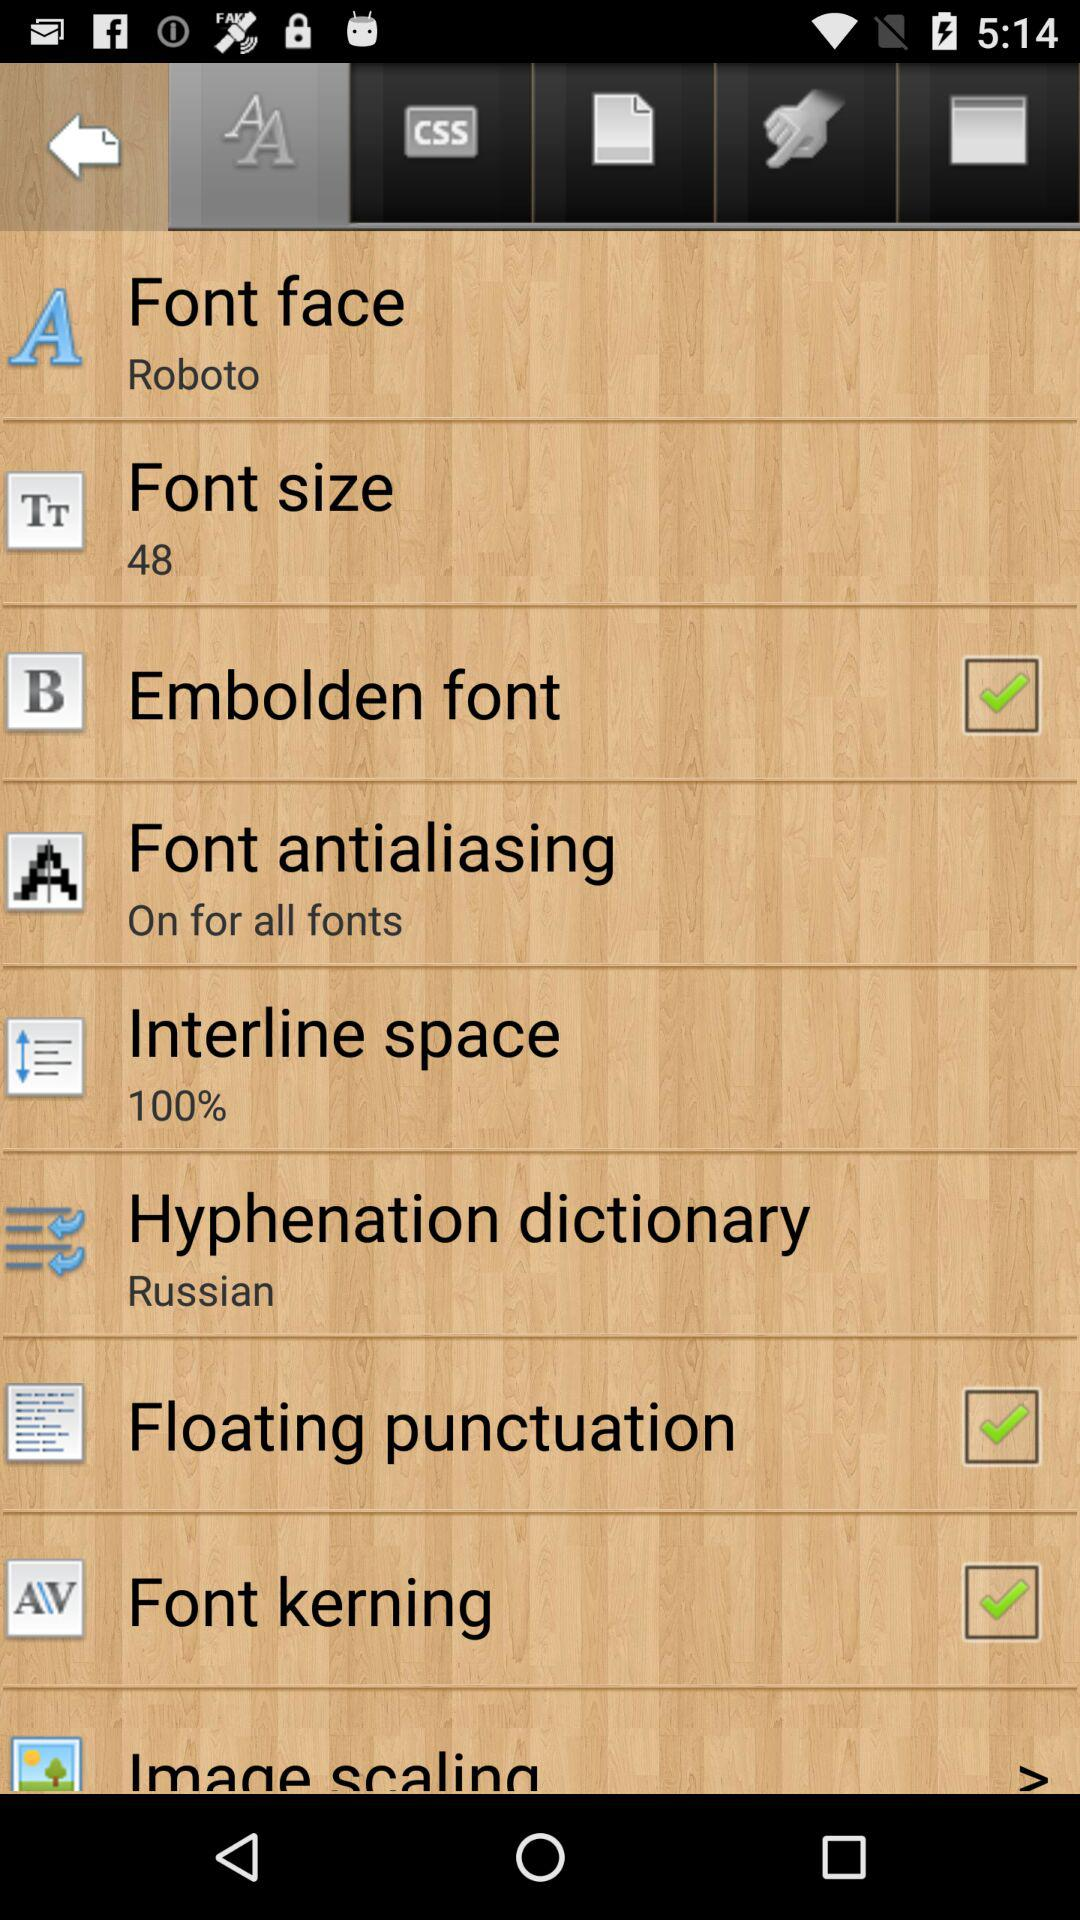What is the status of "Font kerning"? The status is on. 